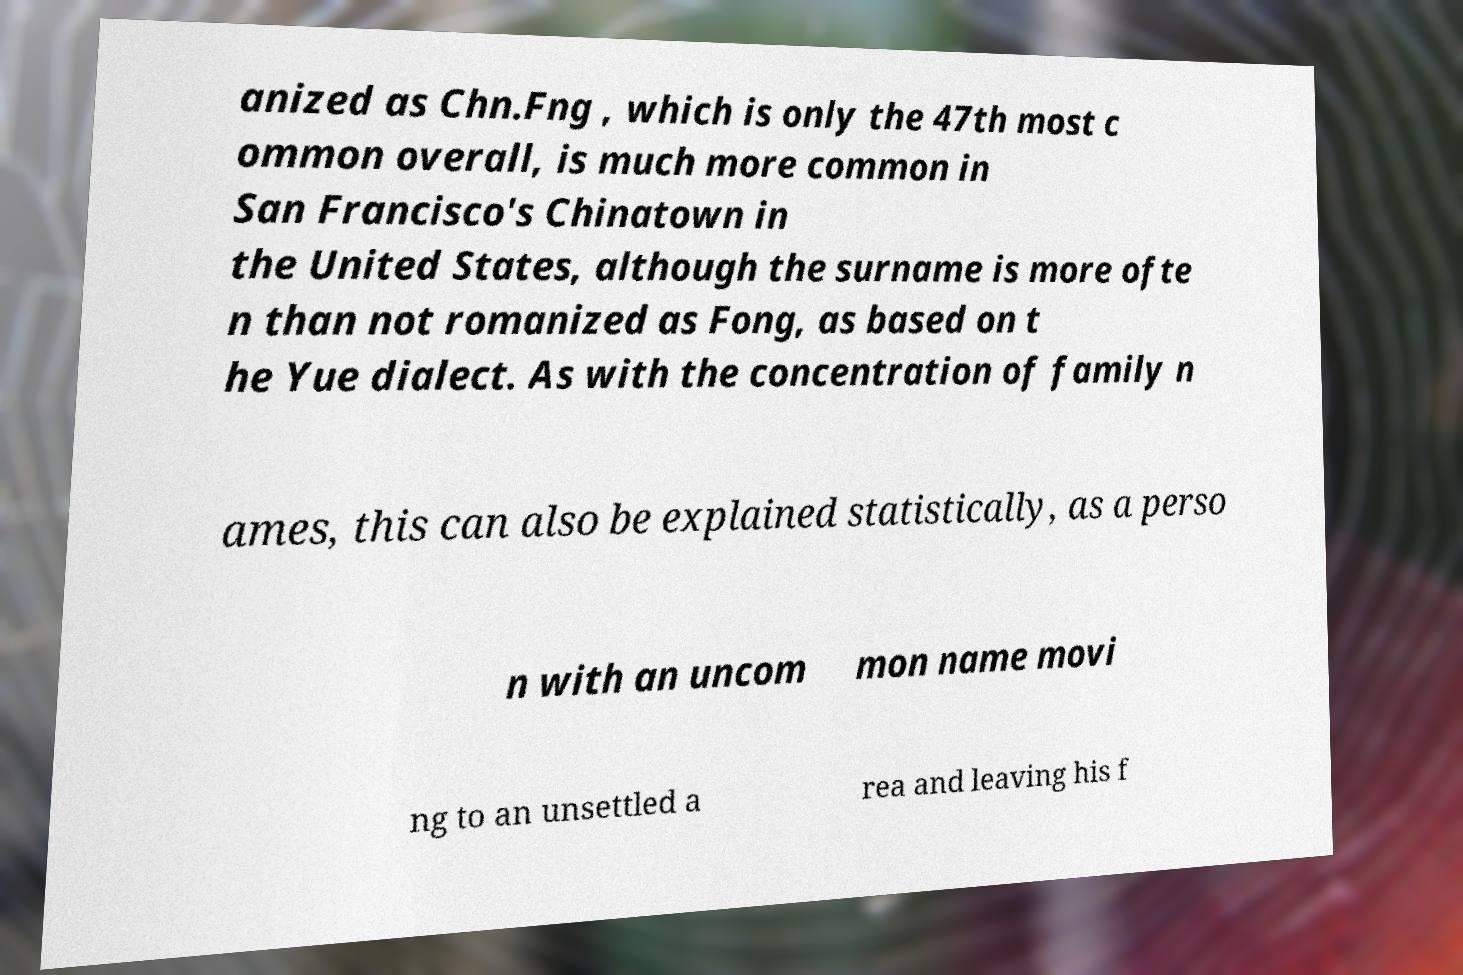Please read and relay the text visible in this image. What does it say? anized as Chn.Fng , which is only the 47th most c ommon overall, is much more common in San Francisco's Chinatown in the United States, although the surname is more ofte n than not romanized as Fong, as based on t he Yue dialect. As with the concentration of family n ames, this can also be explained statistically, as a perso n with an uncom mon name movi ng to an unsettled a rea and leaving his f 